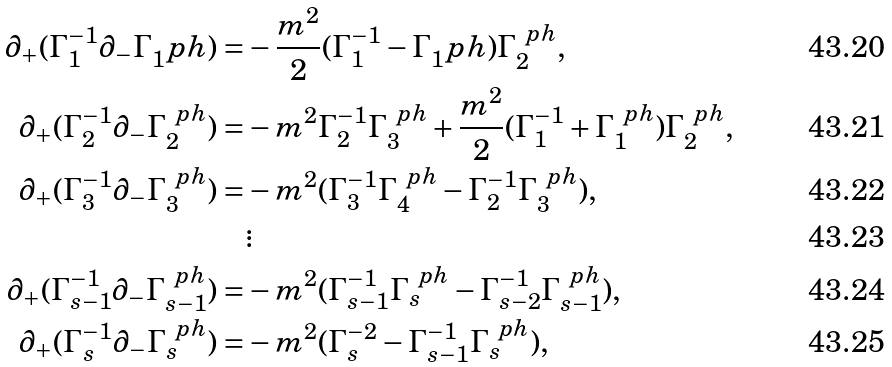Convert formula to latex. <formula><loc_0><loc_0><loc_500><loc_500>\partial _ { + } ( \Gamma _ { 1 } ^ { - 1 } \partial _ { - } \Gamma _ { 1 } ^ { \ } p h ) = & - \frac { m ^ { 2 } } { 2 } ( \Gamma _ { 1 } ^ { - 1 } - \Gamma _ { 1 } ^ { \ } p h ) \Gamma _ { 2 } ^ { \ p h } , \\ \partial _ { + } ( \Gamma _ { 2 } ^ { - 1 } \partial _ { - } \Gamma _ { 2 } ^ { \ p h } ) = & - m ^ { 2 } \Gamma _ { 2 } ^ { - 1 } \Gamma _ { 3 } ^ { \ p h } + \frac { m ^ { 2 } } { 2 } ( \Gamma _ { 1 } ^ { - 1 } + \Gamma _ { 1 } ^ { \ p h } ) \Gamma _ { 2 } ^ { \ p h } , \\ \partial _ { + } ( \Gamma _ { 3 } ^ { - 1 } \partial _ { - } \Gamma _ { 3 } ^ { \ p h } ) = & - m ^ { 2 } ( \Gamma _ { 3 } ^ { - 1 } \Gamma _ { 4 } ^ { \ p h } - \Gamma _ { 2 } ^ { - 1 } \Gamma _ { 3 } ^ { \ p h } ) , \\ & \vdots \\ \partial _ { + } ( \Gamma _ { s - 1 } ^ { - 1 } \partial _ { - } \Gamma _ { s - 1 } ^ { \ p h } ) = & - m ^ { 2 } ( \Gamma _ { s - 1 } ^ { - 1 } \Gamma _ { s } ^ { \ p h } - \Gamma _ { s - 2 } ^ { - 1 } \Gamma _ { s - 1 } ^ { \ p h } ) , \\ \partial _ { + } ( \Gamma _ { s } ^ { - 1 } \partial _ { - } \Gamma _ { s } ^ { \ p h } ) = & - m ^ { 2 } ( \Gamma _ { s } ^ { - 2 } - \Gamma _ { s - 1 } ^ { - 1 } \Gamma _ { s } ^ { \ p h } ) ,</formula> 